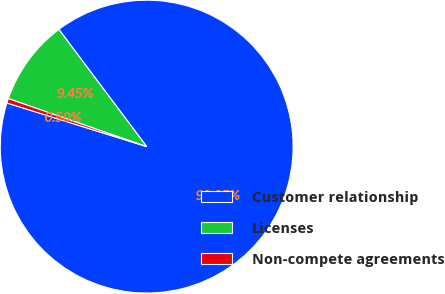Convert chart to OTSL. <chart><loc_0><loc_0><loc_500><loc_500><pie_chart><fcel>Customer relationship<fcel>Licenses<fcel>Non-compete agreements<nl><fcel>90.05%<fcel>9.45%<fcel>0.5%<nl></chart> 